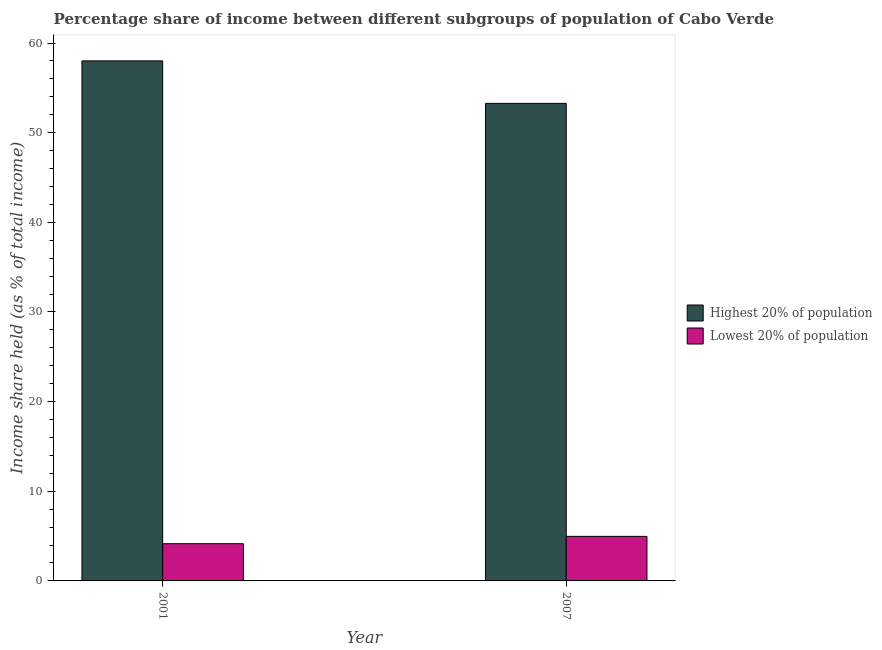Are the number of bars per tick equal to the number of legend labels?
Your answer should be compact. Yes. Are the number of bars on each tick of the X-axis equal?
Give a very brief answer. Yes. How many bars are there on the 2nd tick from the left?
Offer a terse response. 2. What is the label of the 1st group of bars from the left?
Provide a short and direct response. 2001. What is the income share held by highest 20% of the population in 2001?
Offer a very short reply. 58.01. Across all years, what is the maximum income share held by highest 20% of the population?
Provide a succinct answer. 58.01. Across all years, what is the minimum income share held by lowest 20% of the population?
Ensure brevity in your answer.  4.15. In which year was the income share held by highest 20% of the population maximum?
Keep it short and to the point. 2001. In which year was the income share held by lowest 20% of the population minimum?
Ensure brevity in your answer.  2001. What is the total income share held by lowest 20% of the population in the graph?
Your answer should be very brief. 9.12. What is the difference between the income share held by lowest 20% of the population in 2001 and that in 2007?
Your answer should be compact. -0.82. What is the difference between the income share held by lowest 20% of the population in 2001 and the income share held by highest 20% of the population in 2007?
Offer a terse response. -0.82. What is the average income share held by lowest 20% of the population per year?
Make the answer very short. 4.56. In the year 2001, what is the difference between the income share held by highest 20% of the population and income share held by lowest 20% of the population?
Make the answer very short. 0. What is the ratio of the income share held by lowest 20% of the population in 2001 to that in 2007?
Your response must be concise. 0.84. Is the income share held by highest 20% of the population in 2001 less than that in 2007?
Your response must be concise. No. In how many years, is the income share held by highest 20% of the population greater than the average income share held by highest 20% of the population taken over all years?
Keep it short and to the point. 1. What does the 2nd bar from the left in 2007 represents?
Ensure brevity in your answer.  Lowest 20% of population. What does the 1st bar from the right in 2007 represents?
Your answer should be compact. Lowest 20% of population. How many bars are there?
Give a very brief answer. 4. Are all the bars in the graph horizontal?
Provide a succinct answer. No. What is the difference between two consecutive major ticks on the Y-axis?
Make the answer very short. 10. Does the graph contain any zero values?
Give a very brief answer. No. What is the title of the graph?
Provide a succinct answer. Percentage share of income between different subgroups of population of Cabo Verde. What is the label or title of the X-axis?
Make the answer very short. Year. What is the label or title of the Y-axis?
Provide a succinct answer. Income share held (as % of total income). What is the Income share held (as % of total income) in Highest 20% of population in 2001?
Ensure brevity in your answer.  58.01. What is the Income share held (as % of total income) in Lowest 20% of population in 2001?
Provide a short and direct response. 4.15. What is the Income share held (as % of total income) of Highest 20% of population in 2007?
Your answer should be compact. 53.27. What is the Income share held (as % of total income) of Lowest 20% of population in 2007?
Make the answer very short. 4.97. Across all years, what is the maximum Income share held (as % of total income) of Highest 20% of population?
Provide a short and direct response. 58.01. Across all years, what is the maximum Income share held (as % of total income) in Lowest 20% of population?
Keep it short and to the point. 4.97. Across all years, what is the minimum Income share held (as % of total income) of Highest 20% of population?
Provide a succinct answer. 53.27. Across all years, what is the minimum Income share held (as % of total income) of Lowest 20% of population?
Offer a very short reply. 4.15. What is the total Income share held (as % of total income) in Highest 20% of population in the graph?
Provide a short and direct response. 111.28. What is the total Income share held (as % of total income) in Lowest 20% of population in the graph?
Give a very brief answer. 9.12. What is the difference between the Income share held (as % of total income) in Highest 20% of population in 2001 and that in 2007?
Provide a succinct answer. 4.74. What is the difference between the Income share held (as % of total income) in Lowest 20% of population in 2001 and that in 2007?
Your response must be concise. -0.82. What is the difference between the Income share held (as % of total income) in Highest 20% of population in 2001 and the Income share held (as % of total income) in Lowest 20% of population in 2007?
Keep it short and to the point. 53.04. What is the average Income share held (as % of total income) in Highest 20% of population per year?
Offer a terse response. 55.64. What is the average Income share held (as % of total income) in Lowest 20% of population per year?
Offer a very short reply. 4.56. In the year 2001, what is the difference between the Income share held (as % of total income) of Highest 20% of population and Income share held (as % of total income) of Lowest 20% of population?
Give a very brief answer. 53.86. In the year 2007, what is the difference between the Income share held (as % of total income) of Highest 20% of population and Income share held (as % of total income) of Lowest 20% of population?
Provide a succinct answer. 48.3. What is the ratio of the Income share held (as % of total income) of Highest 20% of population in 2001 to that in 2007?
Give a very brief answer. 1.09. What is the ratio of the Income share held (as % of total income) in Lowest 20% of population in 2001 to that in 2007?
Give a very brief answer. 0.83. What is the difference between the highest and the second highest Income share held (as % of total income) of Highest 20% of population?
Keep it short and to the point. 4.74. What is the difference between the highest and the second highest Income share held (as % of total income) in Lowest 20% of population?
Offer a terse response. 0.82. What is the difference between the highest and the lowest Income share held (as % of total income) of Highest 20% of population?
Offer a very short reply. 4.74. What is the difference between the highest and the lowest Income share held (as % of total income) in Lowest 20% of population?
Provide a short and direct response. 0.82. 